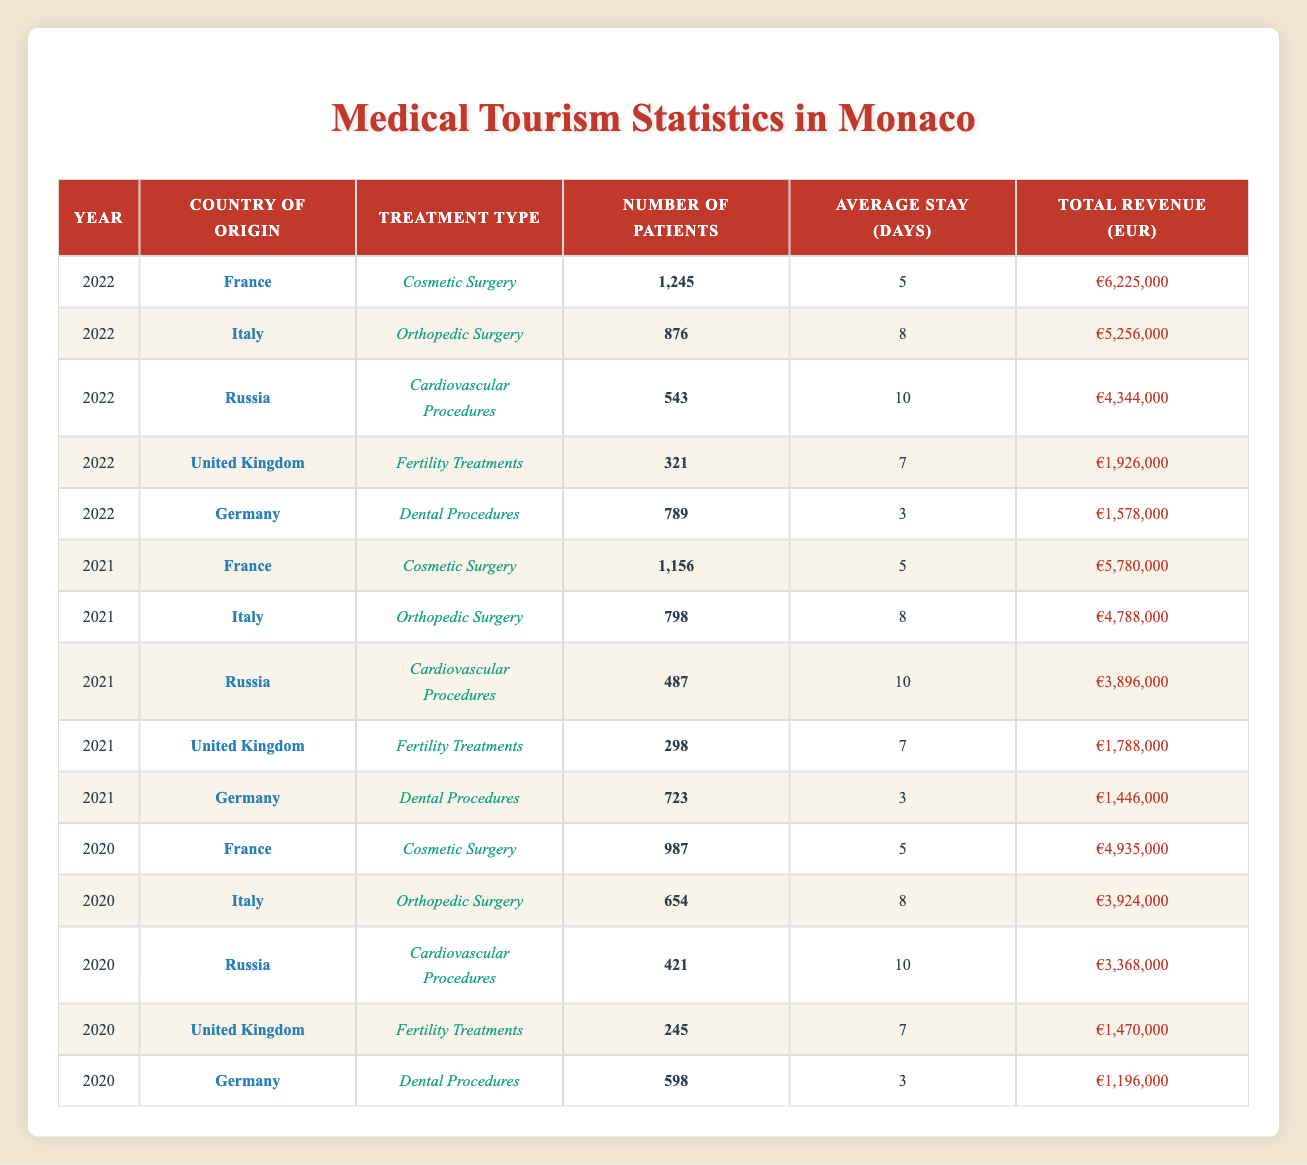What was the total number of patients from France in 2022? In 2022, the table shows that France had 1,245 patients for Cosmetic Surgery. Since this is the only entry for France in 2022, the total number of patients is simply 1,245.
Answer: 1,245 What was the average stay in days for Russian patients undergoing Cardiovascular Procedures in 2022? The relevant row for Russian patients in 2022 indicates that they had an average stay of 10 days for Cardiovascular Procedures. Thus, the answer is directly taken from this entry.
Answer: 10 Did Italy have any patients seeking Dental Procedures in 2021? By reviewing the table for Italy in 2021, it is clear that there were only patients listed for Orthopedic Surgery, with zero entries for Dental Procedures. Therefore, the statement is false.
Answer: No Which treatment type generated the highest revenue in 2022, and what was the amount? Comparing total revenue across all treatment types in 2022, Cosmetic Surgery (France) generated €6,225,000, which is higher than the other treatment types listed for that year.
Answer: Cosmetic Surgery, €6,225,000 What was the difference in the number of patients from the UK between 2021 and 2022 for Fertility Treatments? The UK had 321 patients in 2022 and 298 patients in 2021 for Fertility Treatments. The difference can be calculated by subtracting the 2021 figure from the 2022 figure: 321 - 298 = 23.
Answer: 23 What is the total revenue generated from Orthopedic Surgery for all countries combined in 2021? In 2021, Italy had 798 patients and generated €4,788,000 for Orthopedic Surgery. There are no entries for other countries in this treatment type for that year, so the total revenue for Orthopedic Surgery in 2021 is solely from Italy, which is €4,788,000.
Answer: €4,788,000 How many patients came from Germany across all years for Dental Procedures? Examining each year shown, Germany had 789 patients in 2022, 723 patients in 2021, and 598 patients in 2020 for Dental Procedures. Summing these gives: 789 + 723 + 598 = 2,110.
Answer: 2,110 Was there an increasing trend in the number of patients from France undergoing Cosmetic Surgery from 2020 to 2022? France had 987 patients in 2020, 1,156 patients in 2021, and 1,245 patients in 2022 for Cosmetic Surgery. Noticing that these numbers increase each year indicates there is indeed an increasing trend.
Answer: Yes 